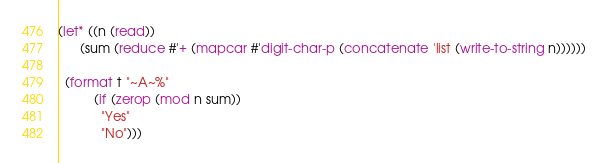<code> <loc_0><loc_0><loc_500><loc_500><_Lisp_>(let* ((n (read))
      (sum (reduce #'+ (mapcar #'digit-char-p (concatenate 'list (write-to-string n))))))

  (format t "~A~%"
          (if (zerop (mod n sum))
            "Yes"
            "No")))
</code> 